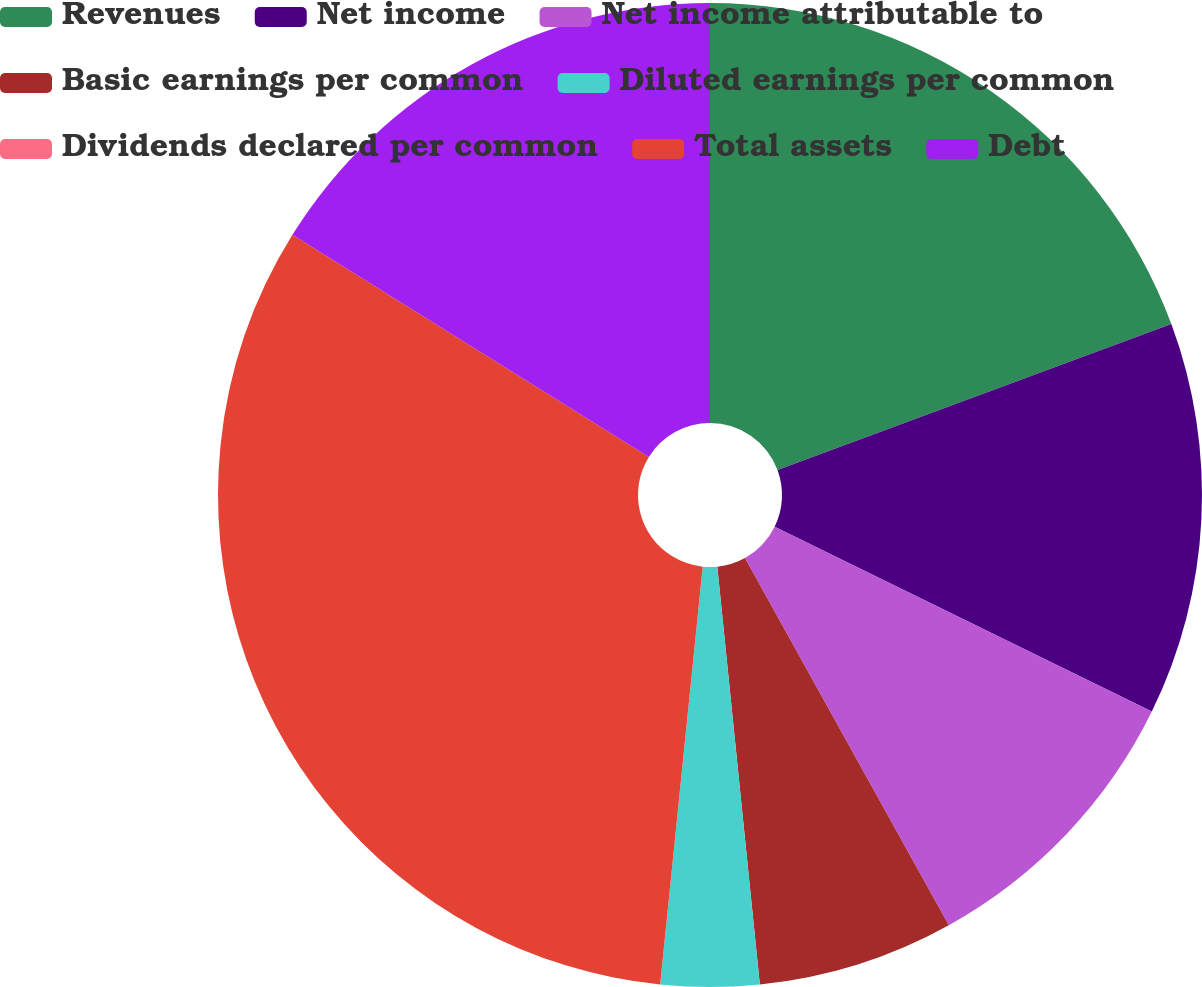Convert chart to OTSL. <chart><loc_0><loc_0><loc_500><loc_500><pie_chart><fcel>Revenues<fcel>Net income<fcel>Net income attributable to<fcel>Basic earnings per common<fcel>Diluted earnings per common<fcel>Dividends declared per common<fcel>Total assets<fcel>Debt<nl><fcel>19.35%<fcel>12.9%<fcel>9.68%<fcel>6.45%<fcel>3.23%<fcel>0.0%<fcel>32.25%<fcel>16.13%<nl></chart> 